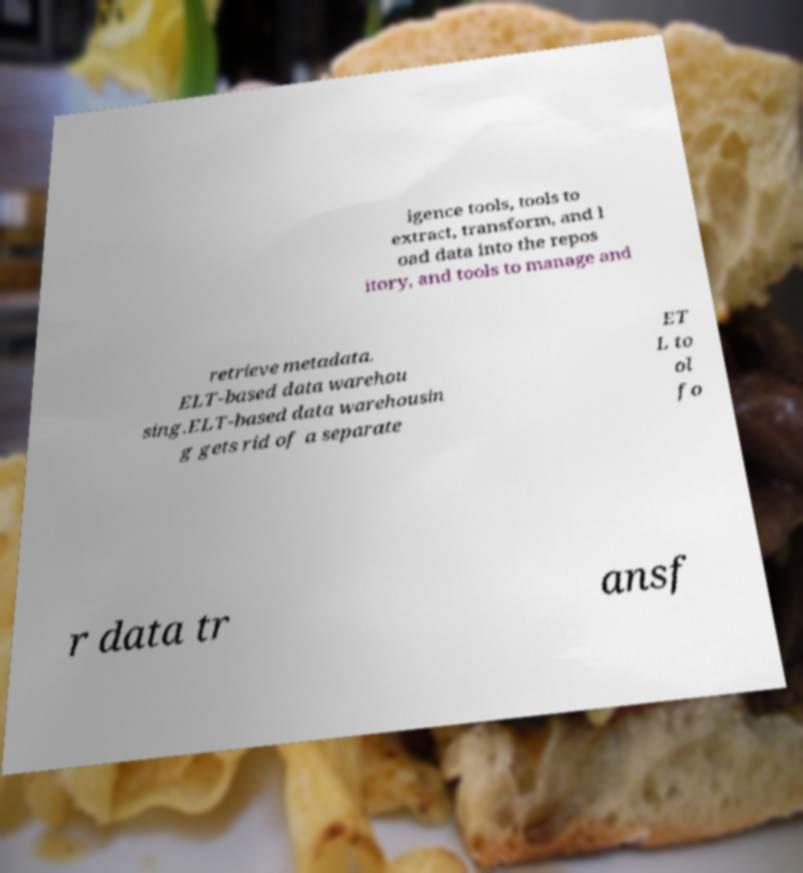Please read and relay the text visible in this image. What does it say? igence tools, tools to extract, transform, and l oad data into the repos itory, and tools to manage and retrieve metadata. ELT-based data warehou sing.ELT-based data warehousin g gets rid of a separate ET L to ol fo r data tr ansf 